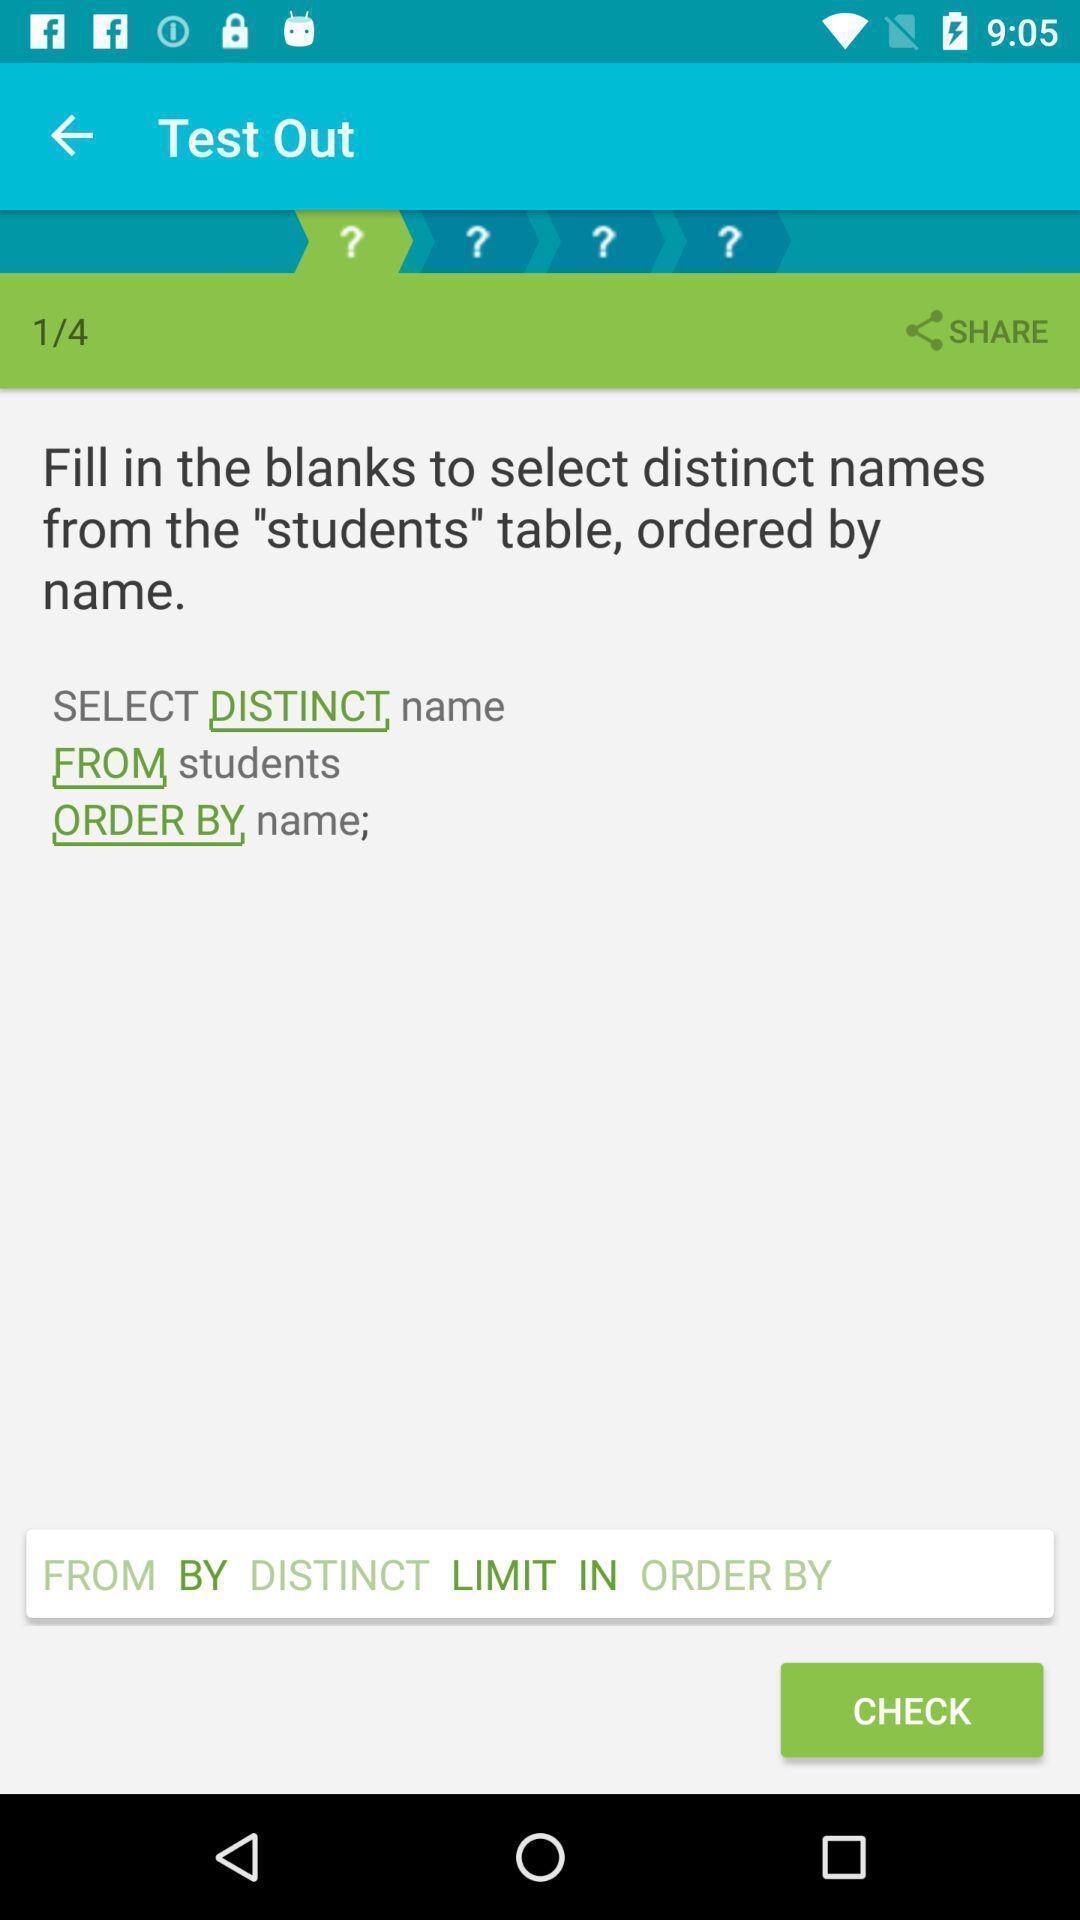Provide a detailed account of this screenshot. Test results of the question to check option on app. 